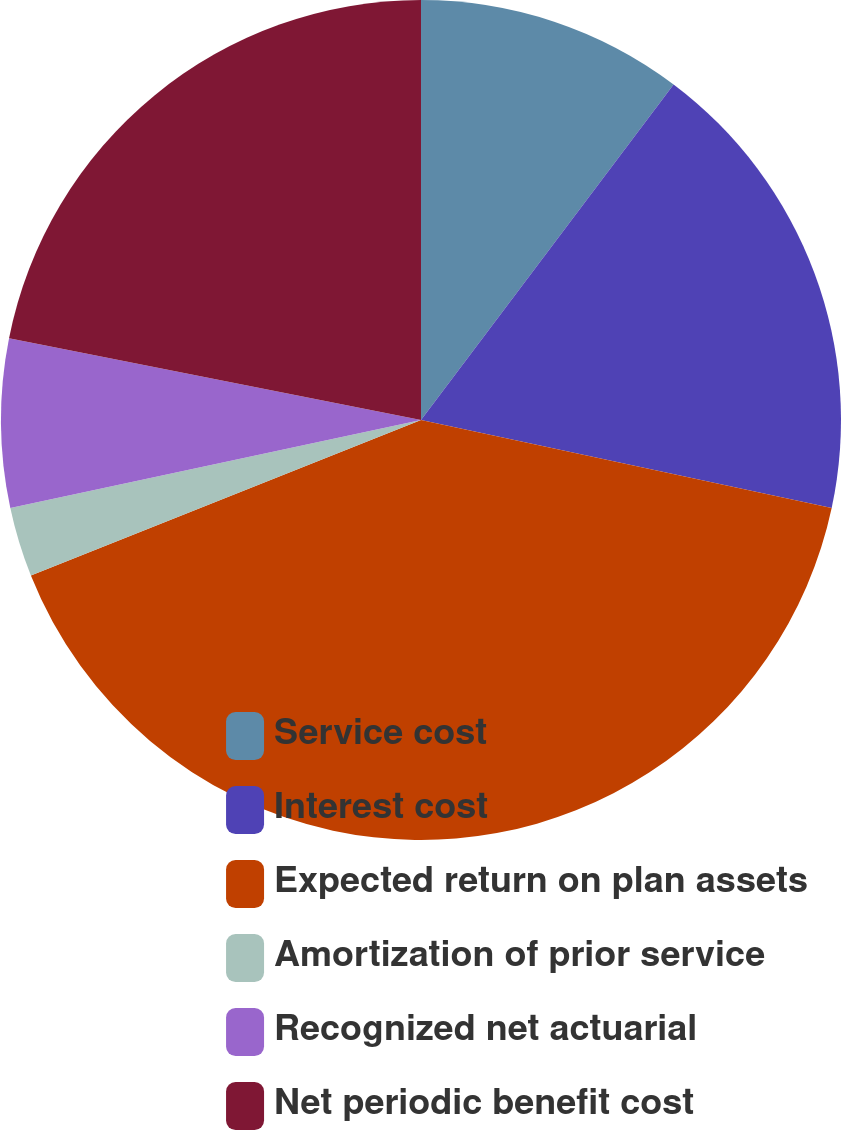Convert chart to OTSL. <chart><loc_0><loc_0><loc_500><loc_500><pie_chart><fcel>Service cost<fcel>Interest cost<fcel>Expected return on plan assets<fcel>Amortization of prior service<fcel>Recognized net actuarial<fcel>Net periodic benefit cost<nl><fcel>10.27%<fcel>18.09%<fcel>40.6%<fcel>2.68%<fcel>6.48%<fcel>21.88%<nl></chart> 